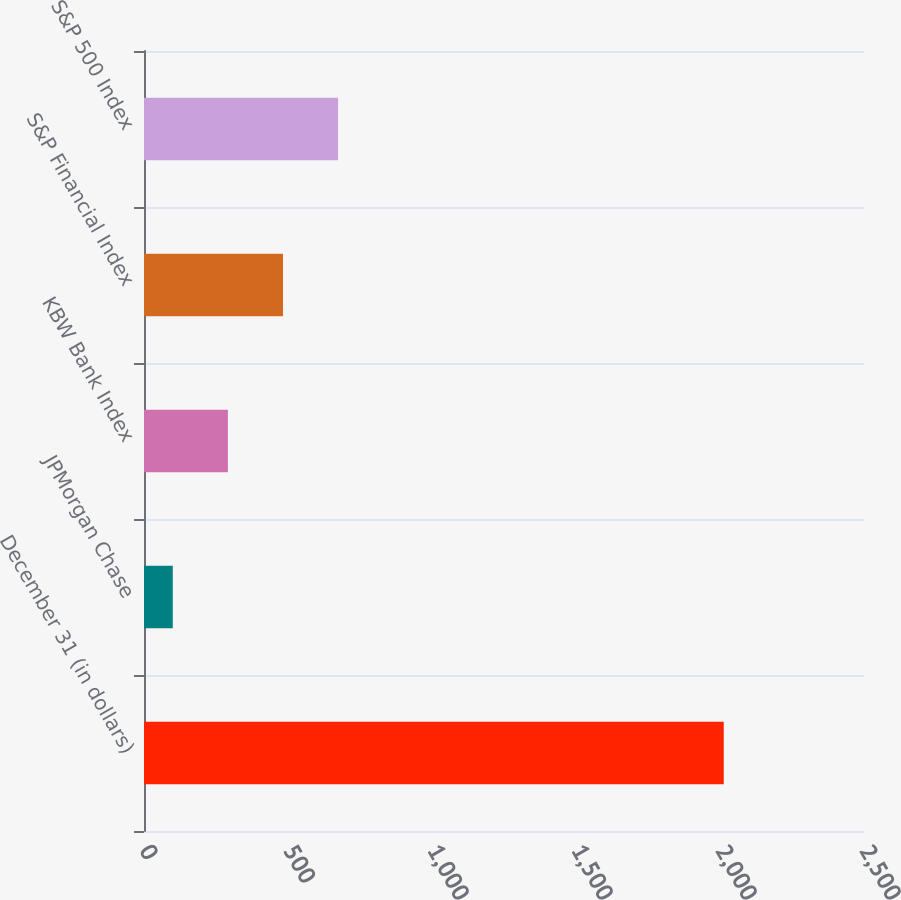Convert chart to OTSL. <chart><loc_0><loc_0><loc_500><loc_500><bar_chart><fcel>December 31 (in dollars)<fcel>JPMorgan Chase<fcel>KBW Bank Index<fcel>S&P Financial Index<fcel>S&P 500 Index<nl><fcel>2013<fcel>100<fcel>291.3<fcel>482.6<fcel>673.9<nl></chart> 